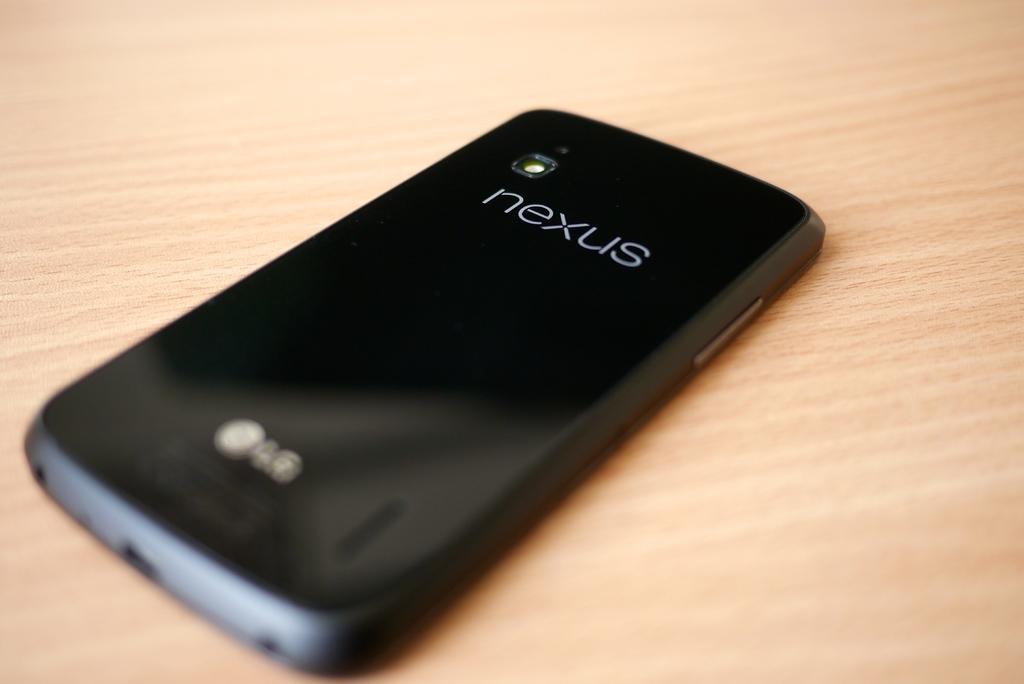What kind of phone is this?
Provide a succinct answer. Nexus. 